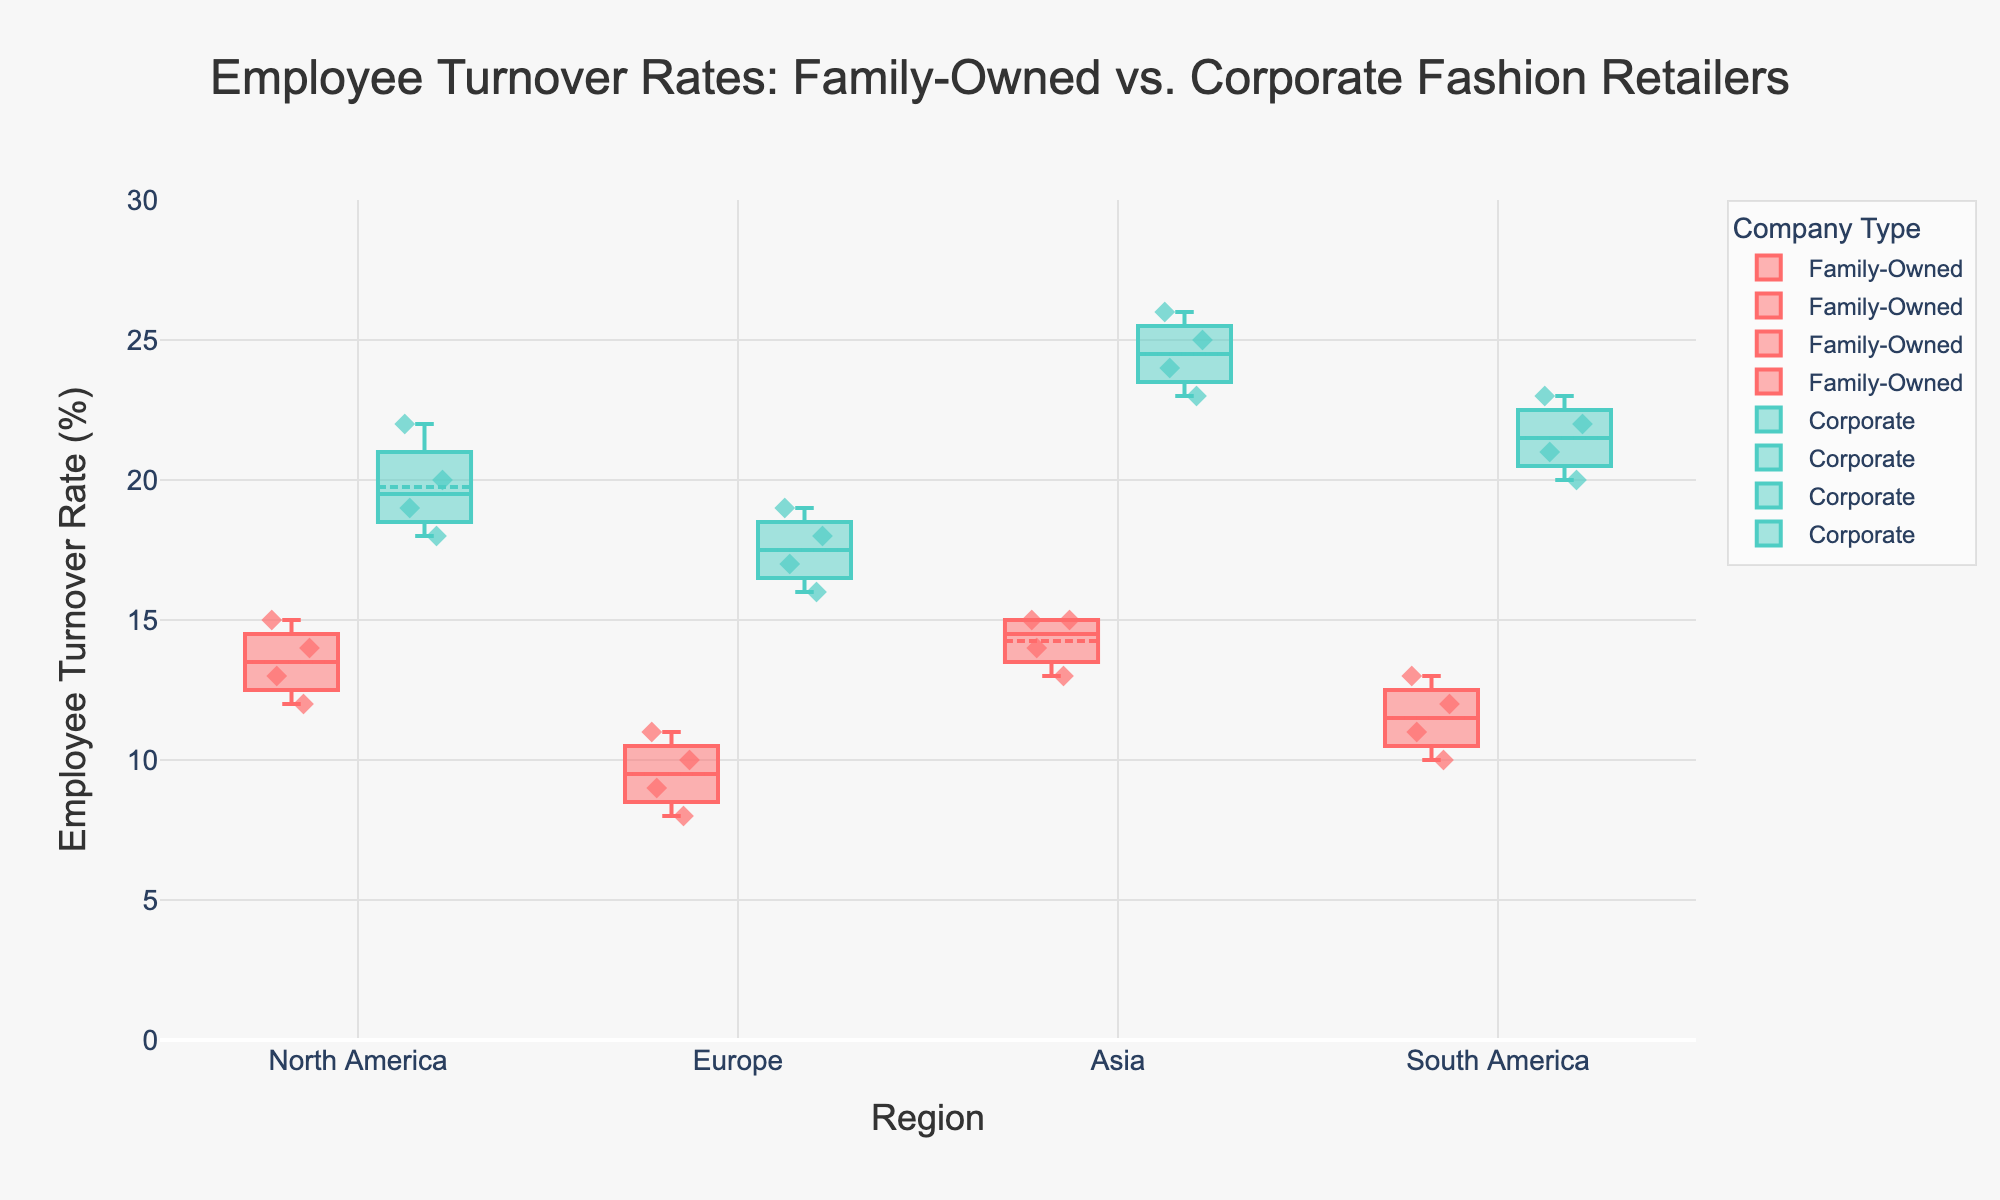what is the title of the plot? There is a title placed at the top of the plot. It reads 'Employee Turnover Rates: Family-Owned vs. Corporate Fashion Retailers'.
Answer: Employee Turnover Rates: Family-Owned vs. Corporate Fashion Retailers How do the employee turnover rates of family-owned retailers in North America compare to those in Europe? By observing the plot, the family-owned retailers in North America have turnover rates in the range of approximately 12-15%, while in Europe, the turnover rates range from roughly 8-11%. So, the turnover rates are higher in North America.
Answer: Higher in North America Which company type has a higher turnover rate in Asia and how can you tell? Looking at the grouped box plots for Asia, the turnover rates for corporate companies range between 23-26%, while for family-owned companies, the rates are between 13-15%. Thus, corporate companies have higher turnover rates in Asia.
Answer: Corporate What is the range of employee turnover rates for family-owned retailers in South America? The box plot shows the range of employee turnover rates for family-owned retailers in South America. The minimum value is 10%, and the maximum is 13%.
Answer: 10-13% What is the median employee turnover rate for corporate retailers in North America? On the box plot for corporate retailers in North America, the median line inside the box corresponds to the median value. This value is around 19%.
Answer: 19% Which region shows the largest difference in employee turnover rates between corporate and family-owned retailers? Examine the range and distribution of the turnover rates for each region. Asia shows the largest spread between corporate (23-26%) and family-owned (13-15%) retailers.
Answer: Asia Are there any regions where family-owned and corporate retailers have overlapping turnover rates? By examining the overlap of the box plots in each group, it is observable that in Europe, the upper range of family-owned (8-11%) overlaps with the lower range of corporate (16-19%).
Answer: Europe What does the boxmean=True option indicate about the plot? The boxmean=True option, visible in how the plot is composed, indicates that the plot includes a mean marker and line for each box, helping to denote the average turnover rate visually.
Answer: Mean marker and line included 